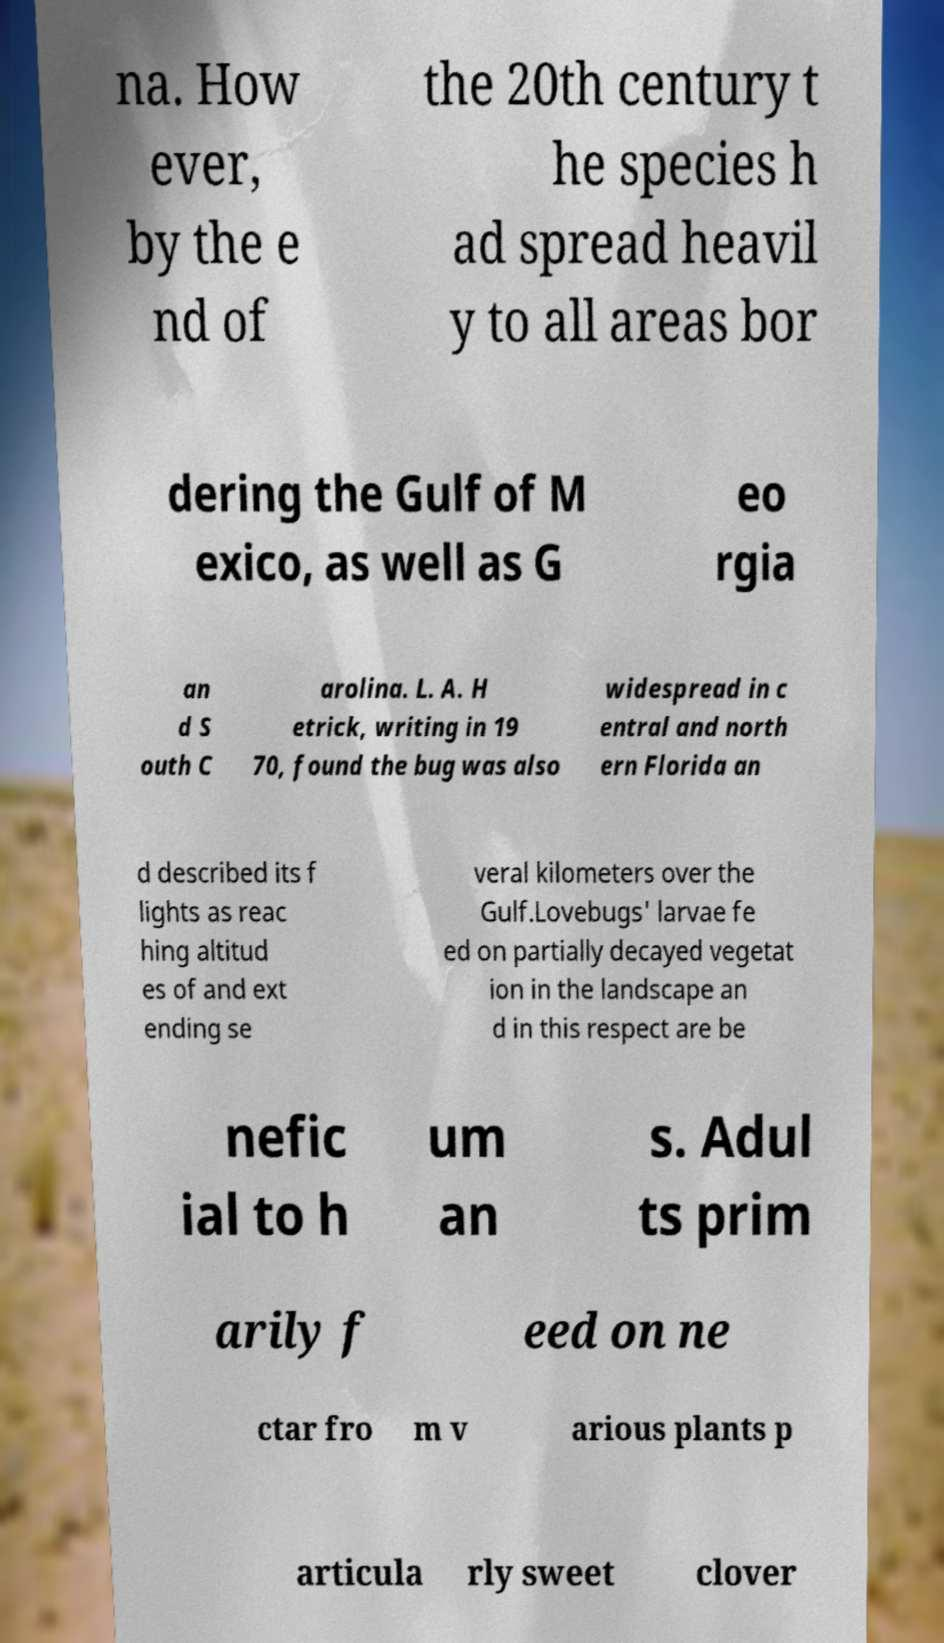Could you assist in decoding the text presented in this image and type it out clearly? na. How ever, by the e nd of the 20th century t he species h ad spread heavil y to all areas bor dering the Gulf of M exico, as well as G eo rgia an d S outh C arolina. L. A. H etrick, writing in 19 70, found the bug was also widespread in c entral and north ern Florida an d described its f lights as reac hing altitud es of and ext ending se veral kilometers over the Gulf.Lovebugs' larvae fe ed on partially decayed vegetat ion in the landscape an d in this respect are be nefic ial to h um an s. Adul ts prim arily f eed on ne ctar fro m v arious plants p articula rly sweet clover 